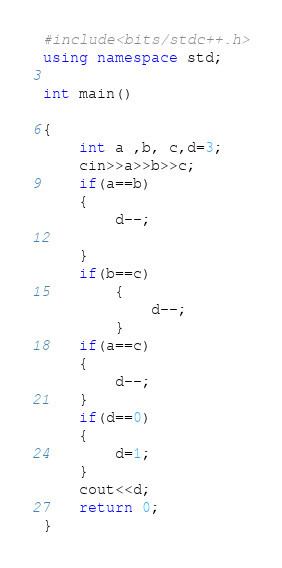Convert code to text. <code><loc_0><loc_0><loc_500><loc_500><_C++_>#include<bits/stdc++.h>
using namespace std;

int main()

{
    int a ,b, c,d=3;
    cin>>a>>b>>c;
    if(a==b)
    {
        d--;

    }
    if(b==c)
        {
            d--;
        }
    if(a==c)
    {
        d--;
    }
    if(d==0)
    {
        d=1;
    }
    cout<<d;
    return 0;
}
</code> 